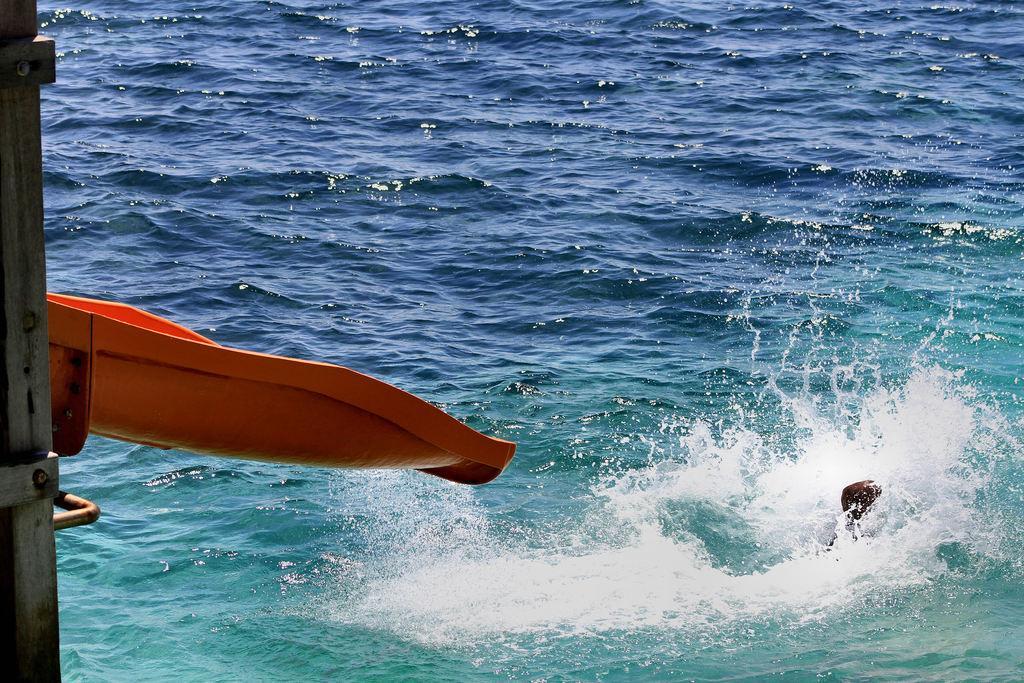In one or two sentences, can you explain what this image depicts? In this image there is water. On the right we can see an object in the water. On the left there is a slide. 